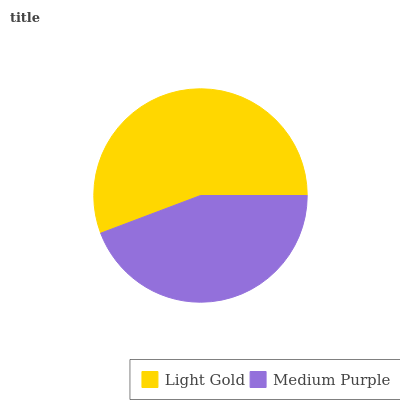Is Medium Purple the minimum?
Answer yes or no. Yes. Is Light Gold the maximum?
Answer yes or no. Yes. Is Medium Purple the maximum?
Answer yes or no. No. Is Light Gold greater than Medium Purple?
Answer yes or no. Yes. Is Medium Purple less than Light Gold?
Answer yes or no. Yes. Is Medium Purple greater than Light Gold?
Answer yes or no. No. Is Light Gold less than Medium Purple?
Answer yes or no. No. Is Light Gold the high median?
Answer yes or no. Yes. Is Medium Purple the low median?
Answer yes or no. Yes. Is Medium Purple the high median?
Answer yes or no. No. Is Light Gold the low median?
Answer yes or no. No. 